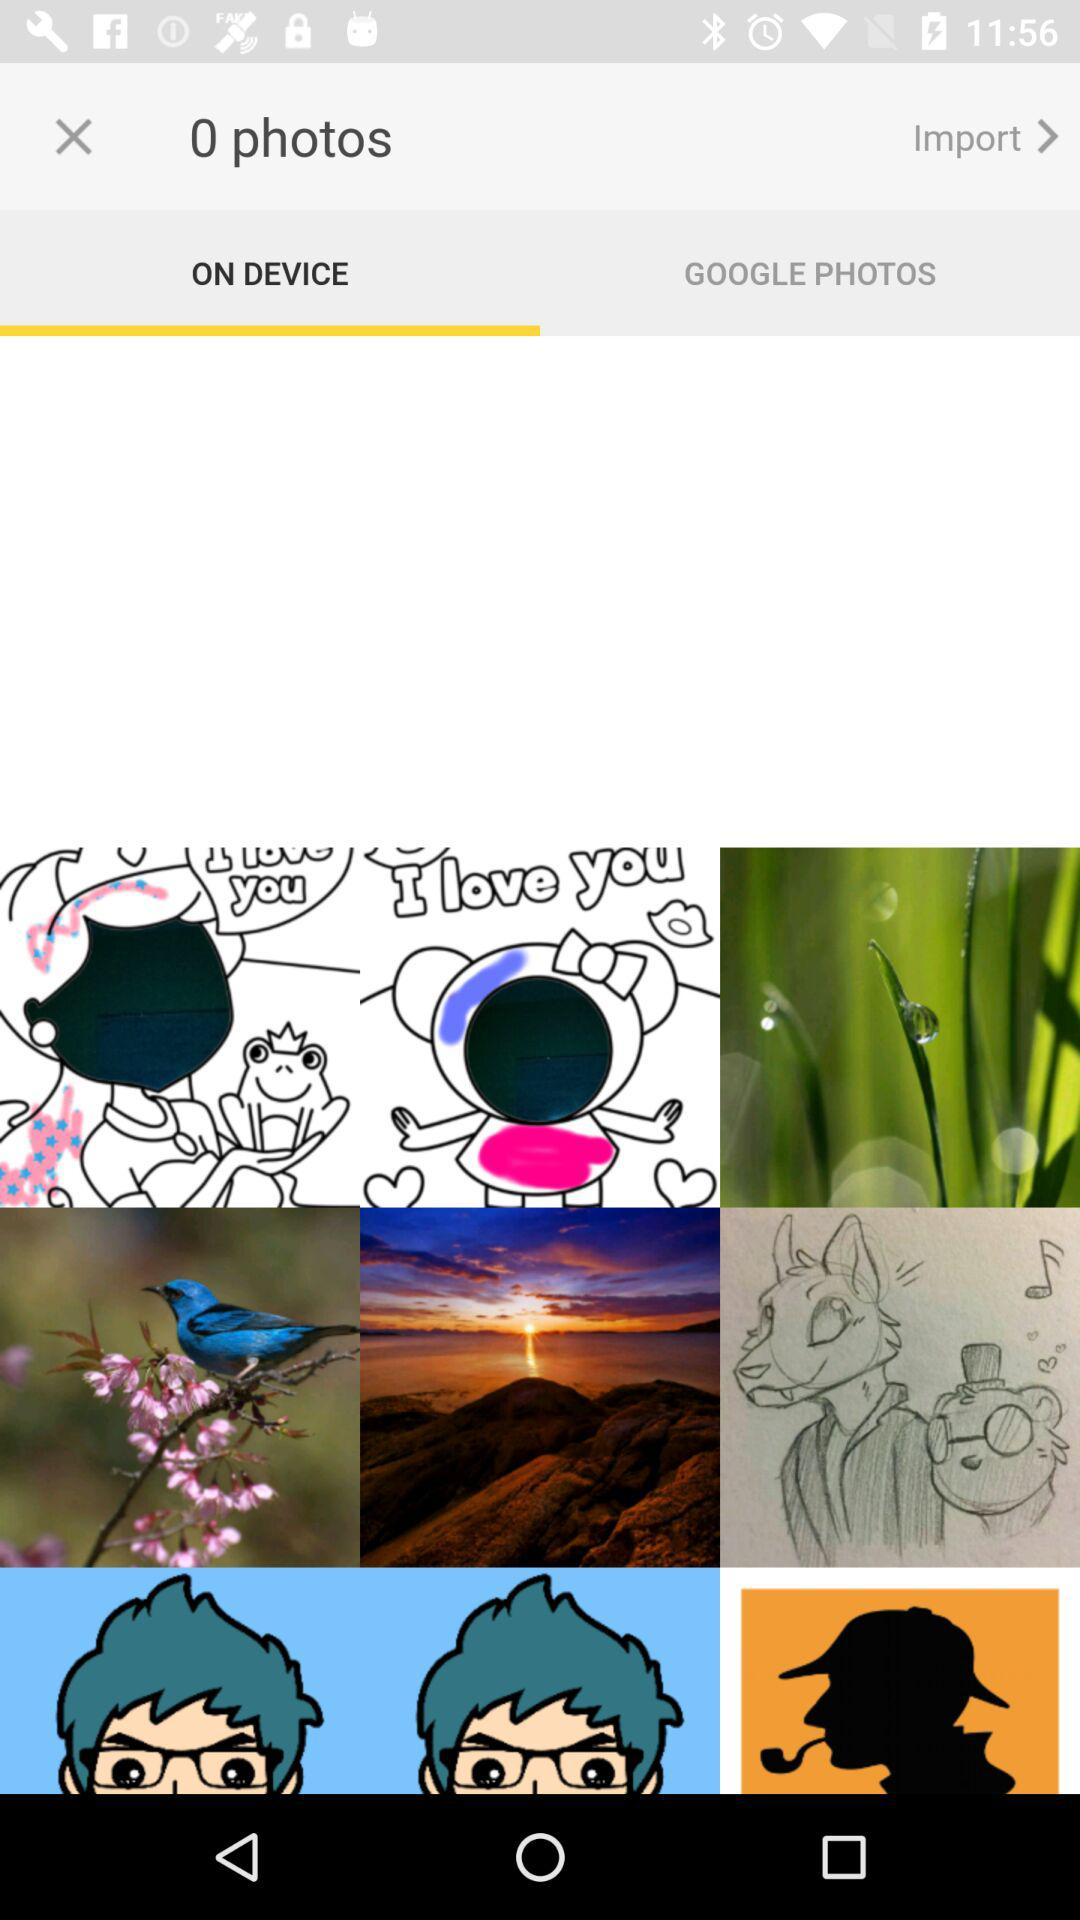Which tab am I on? You are on the tab "ON DEVICE". 